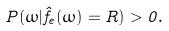<formula> <loc_0><loc_0><loc_500><loc_500>P ( \omega | \hat { f } _ { e } ( \omega ) = R ) > 0 .</formula> 